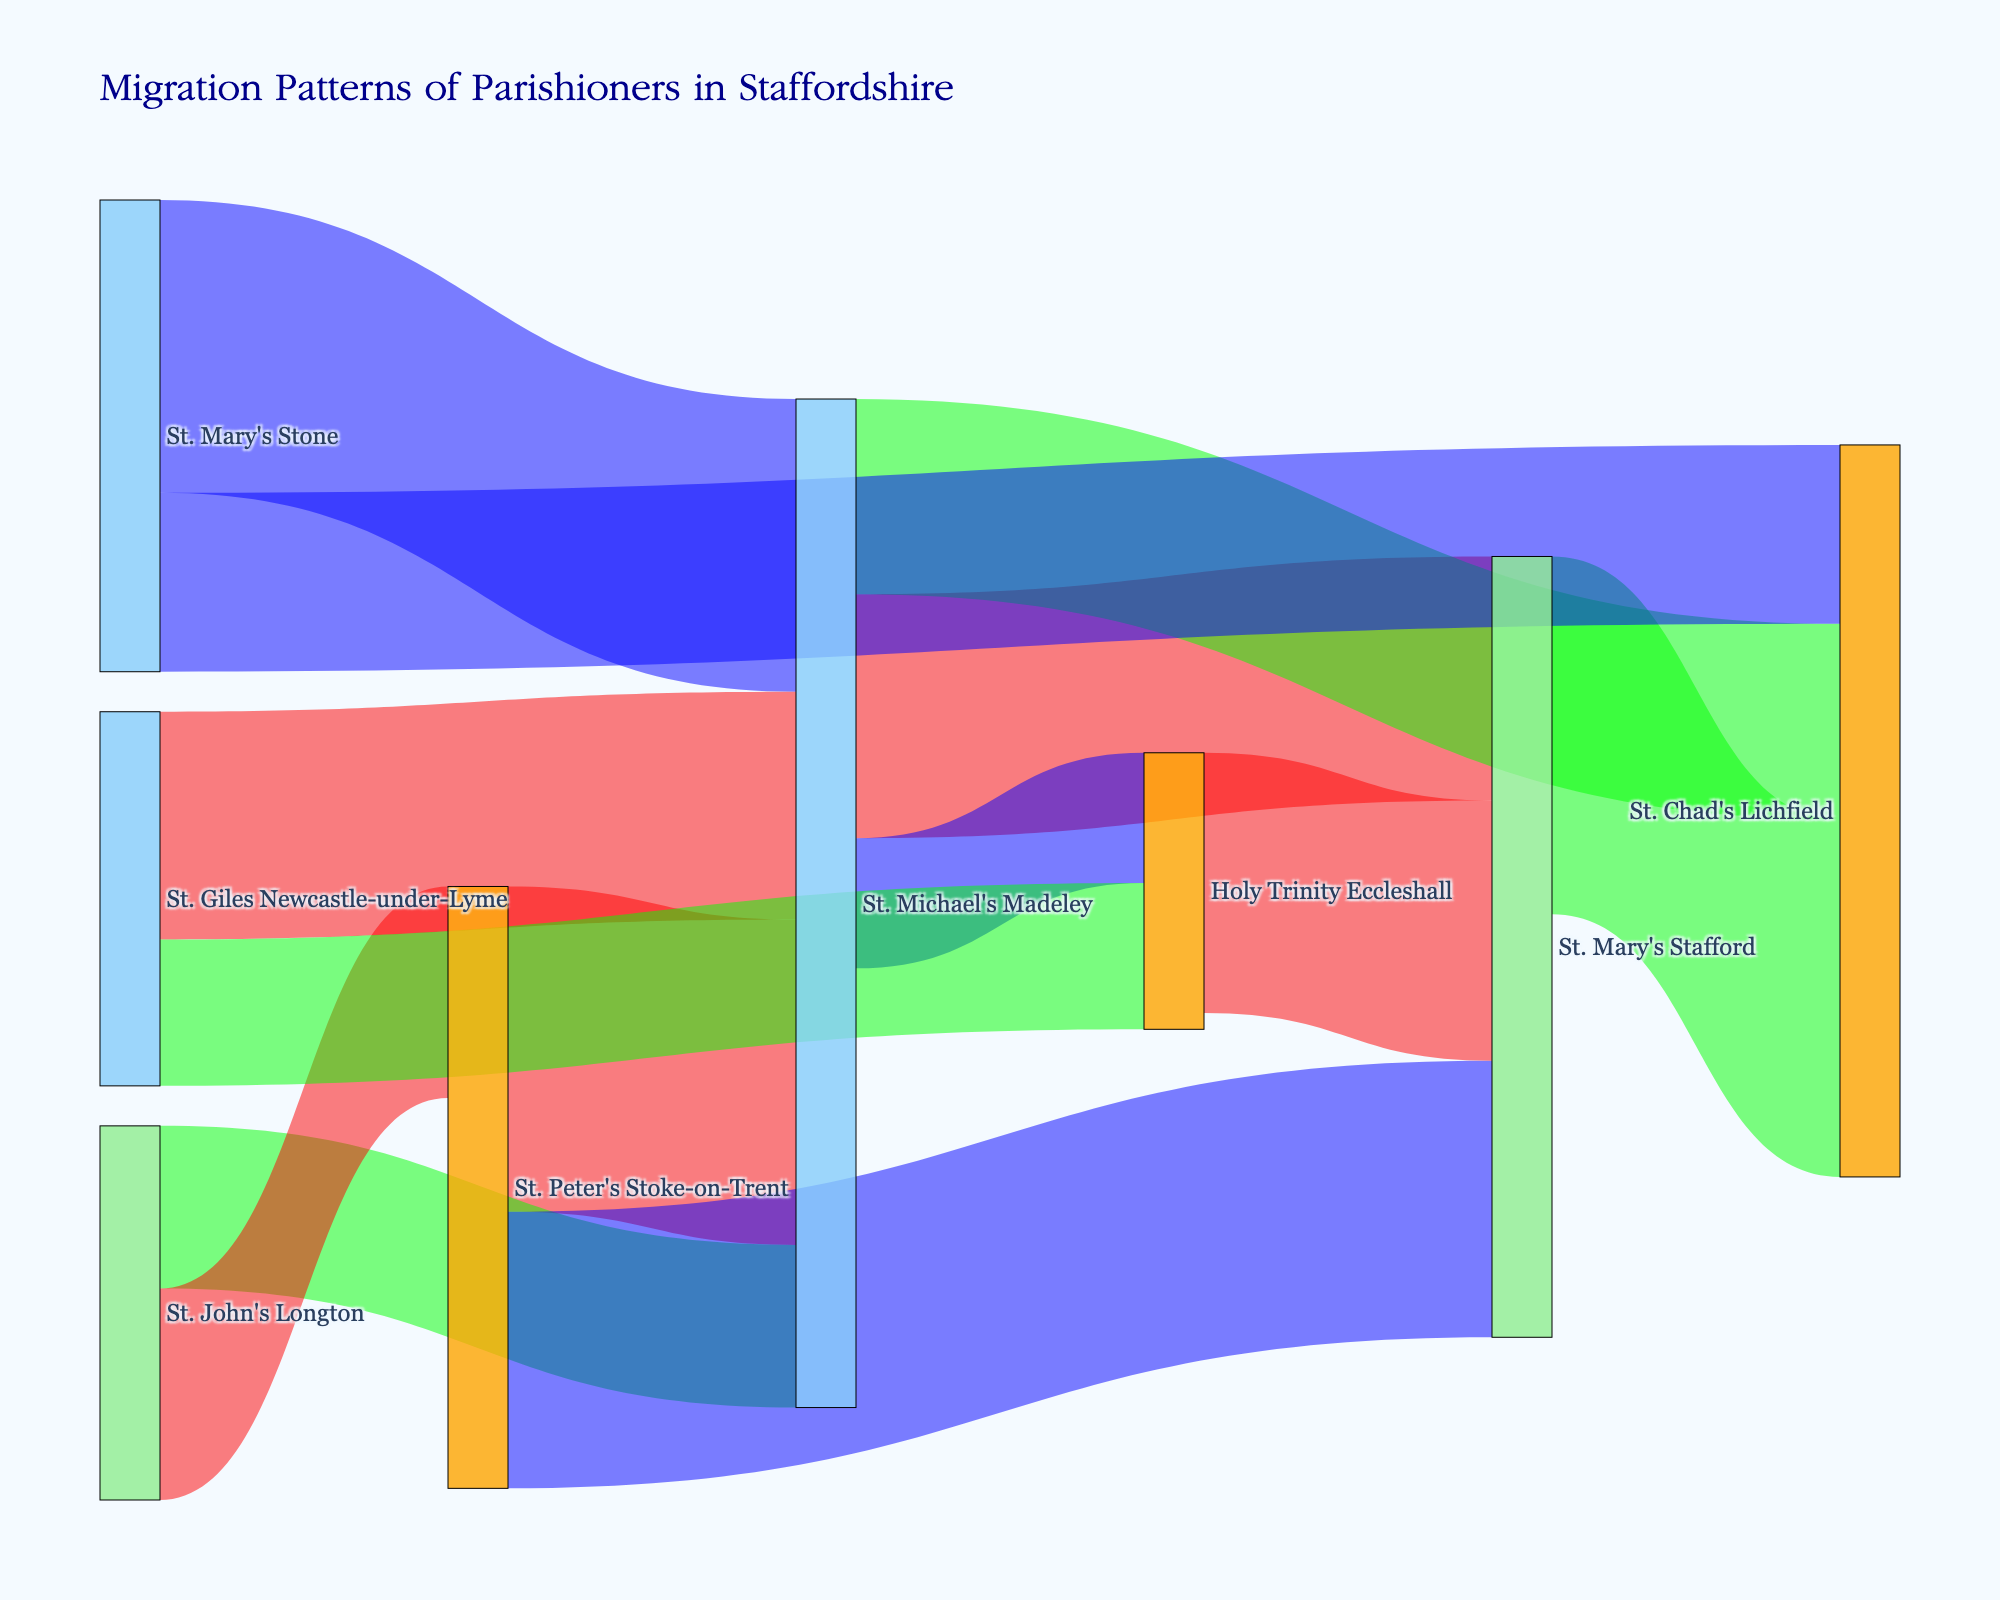Which church has the largest number of parishioners moving to St. Michael's Madeley? By examining the flows into St. Michael's Madeley, the largest value is from St. Peter's Stoke-on-Trent, which is 20 parishioners.
Answer: St. Peter's Stoke-on-Trent What is the total number of parishioners that moved from St. Michael's Madeley to other churches? Summing up the values from St. Michael's Madeley to other churches: 15 (to St. Mary's Stafford) + 12 (to St. Chad's Lichfield) + 8 (to Holy Trinity Eccleshall) = 35.
Answer: 35 Which church did St. Peter's Stoke-on-Trent send the fewest parishioners to? Looking at the links from St. Peter's Stoke-on-Trent, the numbers are 20 (to St. Michael's Madeley) and 17 (to St. Mary's Stafford). Since there are only these two destinations, the smallest number is 17 to St. Mary's Stafford.
Answer: St. Mary's Stafford How many parishioners moved between St. Michael's Madeley and St. Mary's Stafford in total (both directions)? Adding the numbers in both directions: 15 (from St. Michael's Madeley to St. Mary's Stafford) + 18 (from St. Mary's Stone to St. Michael's Madeley) = 33.
Answer: 33 Which church received more parishioners from different sources, St. Michael's Madeley or Holy Trinity Eccleshall? Counting the number of unique sources: St. Michael's Madeley has St. Mary's Stone, St. Peter's Stoke-on-Trent, St. John's Longton, and St. Giles Newcastle-under-Lyme, which is 4. Holy Trinity Eccleshall has St. Michael's Madeley and St. Giles Newcastle-under-Lyme, which is 2.
Answer: St. Michael's Madeley What is the average number of parishioners migrating per flow? Sum all the values: 15 + 12 + 18 + 20 + 10 + 8 + 14 + 22 + 17 + 13 + 9 + 11 + 16 = 185. The total number of flows is 13. Therefore, the average is 185/13 ≈ 14.23.
Answer: ≈ 14.23 